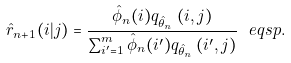Convert formula to latex. <formula><loc_0><loc_0><loc_500><loc_500>\hat { r } _ { n + 1 } ( i | j ) = \frac { \hat { \phi } _ { n } ( i ) q _ { \hat { \theta } _ { n } } \, ( i , j ) } { \sum _ { i ^ { \prime } = 1 } ^ { m } \hat { \phi } _ { n } ( i ^ { \prime } ) q _ { \hat { \theta } _ { n } } \, ( i ^ { \prime } , j ) } \ e q s p .</formula> 